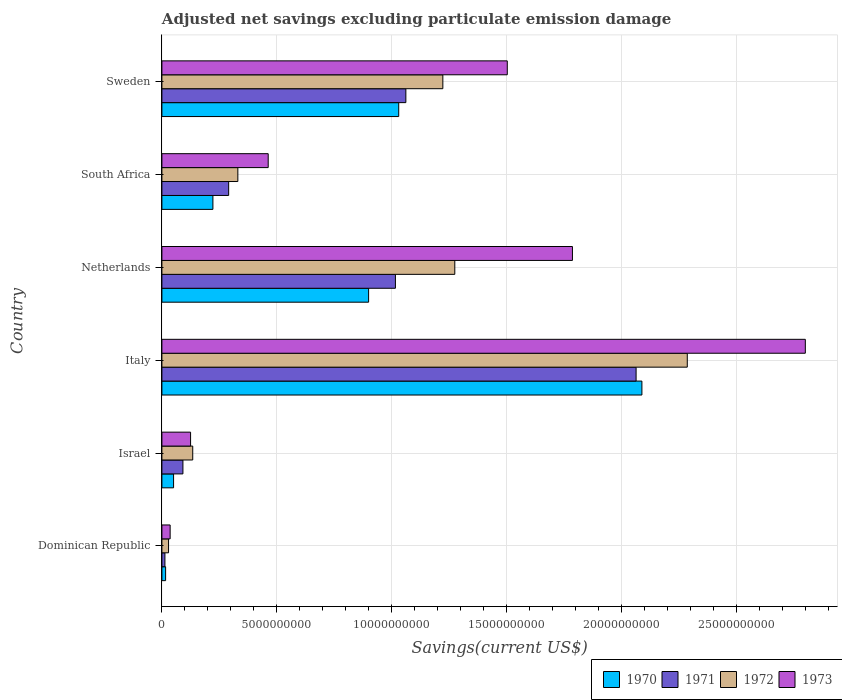How many groups of bars are there?
Provide a short and direct response. 6. How many bars are there on the 1st tick from the top?
Keep it short and to the point. 4. How many bars are there on the 4th tick from the bottom?
Your answer should be compact. 4. What is the label of the 1st group of bars from the top?
Give a very brief answer. Sweden. In how many cases, is the number of bars for a given country not equal to the number of legend labels?
Give a very brief answer. 0. What is the adjusted net savings in 1973 in Israel?
Your answer should be very brief. 1.25e+09. Across all countries, what is the maximum adjusted net savings in 1973?
Your answer should be very brief. 2.80e+1. Across all countries, what is the minimum adjusted net savings in 1972?
Your answer should be compact. 2.89e+08. In which country was the adjusted net savings in 1972 maximum?
Ensure brevity in your answer.  Italy. In which country was the adjusted net savings in 1970 minimum?
Provide a short and direct response. Dominican Republic. What is the total adjusted net savings in 1972 in the graph?
Ensure brevity in your answer.  5.27e+1. What is the difference between the adjusted net savings in 1972 in Dominican Republic and that in Netherlands?
Your answer should be very brief. -1.24e+1. What is the difference between the adjusted net savings in 1971 in Dominican Republic and the adjusted net savings in 1972 in South Africa?
Provide a succinct answer. -3.17e+09. What is the average adjusted net savings in 1972 per country?
Keep it short and to the point. 8.79e+09. What is the difference between the adjusted net savings in 1972 and adjusted net savings in 1973 in Sweden?
Offer a terse response. -2.80e+09. In how many countries, is the adjusted net savings in 1973 greater than 1000000000 US$?
Make the answer very short. 5. What is the ratio of the adjusted net savings in 1973 in Israel to that in South Africa?
Offer a terse response. 0.27. What is the difference between the highest and the second highest adjusted net savings in 1970?
Offer a terse response. 1.06e+1. What is the difference between the highest and the lowest adjusted net savings in 1971?
Provide a short and direct response. 2.05e+1. Is the sum of the adjusted net savings in 1971 in Italy and Netherlands greater than the maximum adjusted net savings in 1973 across all countries?
Your response must be concise. Yes. Is it the case that in every country, the sum of the adjusted net savings in 1971 and adjusted net savings in 1973 is greater than the sum of adjusted net savings in 1970 and adjusted net savings in 1972?
Offer a very short reply. No. What does the 4th bar from the bottom in Italy represents?
Offer a very short reply. 1973. Are all the bars in the graph horizontal?
Give a very brief answer. Yes. Are the values on the major ticks of X-axis written in scientific E-notation?
Your answer should be compact. No. Does the graph contain any zero values?
Offer a terse response. No. What is the title of the graph?
Offer a terse response. Adjusted net savings excluding particulate emission damage. What is the label or title of the X-axis?
Keep it short and to the point. Savings(current US$). What is the Savings(current US$) in 1970 in Dominican Republic?
Your response must be concise. 1.61e+08. What is the Savings(current US$) of 1971 in Dominican Republic?
Ensure brevity in your answer.  1.32e+08. What is the Savings(current US$) of 1972 in Dominican Republic?
Provide a short and direct response. 2.89e+08. What is the Savings(current US$) of 1973 in Dominican Republic?
Your response must be concise. 3.58e+08. What is the Savings(current US$) of 1970 in Israel?
Your response must be concise. 5.08e+08. What is the Savings(current US$) in 1971 in Israel?
Your answer should be very brief. 9.14e+08. What is the Savings(current US$) in 1972 in Israel?
Offer a terse response. 1.34e+09. What is the Savings(current US$) in 1973 in Israel?
Make the answer very short. 1.25e+09. What is the Savings(current US$) in 1970 in Italy?
Keep it short and to the point. 2.09e+1. What is the Savings(current US$) of 1971 in Italy?
Provide a short and direct response. 2.06e+1. What is the Savings(current US$) of 1972 in Italy?
Provide a short and direct response. 2.28e+1. What is the Savings(current US$) in 1973 in Italy?
Give a very brief answer. 2.80e+1. What is the Savings(current US$) of 1970 in Netherlands?
Offer a terse response. 8.99e+09. What is the Savings(current US$) in 1971 in Netherlands?
Give a very brief answer. 1.02e+1. What is the Savings(current US$) in 1972 in Netherlands?
Ensure brevity in your answer.  1.27e+1. What is the Savings(current US$) of 1973 in Netherlands?
Provide a succinct answer. 1.79e+1. What is the Savings(current US$) in 1970 in South Africa?
Provide a short and direct response. 2.22e+09. What is the Savings(current US$) in 1971 in South Africa?
Offer a terse response. 2.90e+09. What is the Savings(current US$) in 1972 in South Africa?
Provide a short and direct response. 3.30e+09. What is the Savings(current US$) of 1973 in South Africa?
Keep it short and to the point. 4.62e+09. What is the Savings(current US$) of 1970 in Sweden?
Your response must be concise. 1.03e+1. What is the Savings(current US$) of 1971 in Sweden?
Your answer should be compact. 1.06e+1. What is the Savings(current US$) in 1972 in Sweden?
Give a very brief answer. 1.22e+1. What is the Savings(current US$) of 1973 in Sweden?
Provide a succinct answer. 1.50e+1. Across all countries, what is the maximum Savings(current US$) in 1970?
Keep it short and to the point. 2.09e+1. Across all countries, what is the maximum Savings(current US$) of 1971?
Offer a very short reply. 2.06e+1. Across all countries, what is the maximum Savings(current US$) of 1972?
Offer a very short reply. 2.28e+1. Across all countries, what is the maximum Savings(current US$) of 1973?
Provide a short and direct response. 2.80e+1. Across all countries, what is the minimum Savings(current US$) in 1970?
Give a very brief answer. 1.61e+08. Across all countries, what is the minimum Savings(current US$) in 1971?
Provide a succinct answer. 1.32e+08. Across all countries, what is the minimum Savings(current US$) of 1972?
Your answer should be very brief. 2.89e+08. Across all countries, what is the minimum Savings(current US$) of 1973?
Offer a very short reply. 3.58e+08. What is the total Savings(current US$) of 1970 in the graph?
Give a very brief answer. 4.30e+1. What is the total Savings(current US$) of 1971 in the graph?
Offer a terse response. 4.53e+1. What is the total Savings(current US$) in 1972 in the graph?
Your response must be concise. 5.27e+1. What is the total Savings(current US$) in 1973 in the graph?
Provide a short and direct response. 6.71e+1. What is the difference between the Savings(current US$) in 1970 in Dominican Republic and that in Israel?
Provide a succinct answer. -3.47e+08. What is the difference between the Savings(current US$) in 1971 in Dominican Republic and that in Israel?
Offer a terse response. -7.83e+08. What is the difference between the Savings(current US$) in 1972 in Dominican Republic and that in Israel?
Keep it short and to the point. -1.05e+09. What is the difference between the Savings(current US$) in 1973 in Dominican Republic and that in Israel?
Provide a short and direct response. -8.89e+08. What is the difference between the Savings(current US$) of 1970 in Dominican Republic and that in Italy?
Provide a succinct answer. -2.07e+1. What is the difference between the Savings(current US$) in 1971 in Dominican Republic and that in Italy?
Your response must be concise. -2.05e+1. What is the difference between the Savings(current US$) of 1972 in Dominican Republic and that in Italy?
Offer a terse response. -2.26e+1. What is the difference between the Savings(current US$) of 1973 in Dominican Republic and that in Italy?
Provide a succinct answer. -2.76e+1. What is the difference between the Savings(current US$) of 1970 in Dominican Republic and that in Netherlands?
Make the answer very short. -8.83e+09. What is the difference between the Savings(current US$) of 1971 in Dominican Republic and that in Netherlands?
Make the answer very short. -1.00e+1. What is the difference between the Savings(current US$) in 1972 in Dominican Republic and that in Netherlands?
Provide a short and direct response. -1.24e+1. What is the difference between the Savings(current US$) in 1973 in Dominican Republic and that in Netherlands?
Provide a short and direct response. -1.75e+1. What is the difference between the Savings(current US$) of 1970 in Dominican Republic and that in South Africa?
Your response must be concise. -2.06e+09. What is the difference between the Savings(current US$) of 1971 in Dominican Republic and that in South Africa?
Offer a terse response. -2.77e+09. What is the difference between the Savings(current US$) in 1972 in Dominican Republic and that in South Africa?
Make the answer very short. -3.01e+09. What is the difference between the Savings(current US$) in 1973 in Dominican Republic and that in South Africa?
Your answer should be very brief. -4.26e+09. What is the difference between the Savings(current US$) in 1970 in Dominican Republic and that in Sweden?
Provide a short and direct response. -1.01e+1. What is the difference between the Savings(current US$) in 1971 in Dominican Republic and that in Sweden?
Your answer should be compact. -1.05e+1. What is the difference between the Savings(current US$) of 1972 in Dominican Republic and that in Sweden?
Your answer should be compact. -1.19e+1. What is the difference between the Savings(current US$) in 1973 in Dominican Republic and that in Sweden?
Your answer should be compact. -1.47e+1. What is the difference between the Savings(current US$) of 1970 in Israel and that in Italy?
Make the answer very short. -2.04e+1. What is the difference between the Savings(current US$) in 1971 in Israel and that in Italy?
Provide a short and direct response. -1.97e+1. What is the difference between the Savings(current US$) of 1972 in Israel and that in Italy?
Offer a terse response. -2.15e+1. What is the difference between the Savings(current US$) of 1973 in Israel and that in Italy?
Keep it short and to the point. -2.67e+1. What is the difference between the Savings(current US$) in 1970 in Israel and that in Netherlands?
Provide a short and direct response. -8.48e+09. What is the difference between the Savings(current US$) of 1971 in Israel and that in Netherlands?
Provide a succinct answer. -9.24e+09. What is the difference between the Savings(current US$) in 1972 in Israel and that in Netherlands?
Offer a terse response. -1.14e+1. What is the difference between the Savings(current US$) in 1973 in Israel and that in Netherlands?
Provide a short and direct response. -1.66e+1. What is the difference between the Savings(current US$) of 1970 in Israel and that in South Africa?
Your answer should be compact. -1.71e+09. What is the difference between the Savings(current US$) of 1971 in Israel and that in South Africa?
Keep it short and to the point. -1.99e+09. What is the difference between the Savings(current US$) in 1972 in Israel and that in South Africa?
Make the answer very short. -1.96e+09. What is the difference between the Savings(current US$) of 1973 in Israel and that in South Africa?
Provide a short and direct response. -3.38e+09. What is the difference between the Savings(current US$) of 1970 in Israel and that in Sweden?
Give a very brief answer. -9.79e+09. What is the difference between the Savings(current US$) in 1971 in Israel and that in Sweden?
Provide a succinct answer. -9.69e+09. What is the difference between the Savings(current US$) of 1972 in Israel and that in Sweden?
Your answer should be very brief. -1.09e+1. What is the difference between the Savings(current US$) of 1973 in Israel and that in Sweden?
Provide a short and direct response. -1.38e+1. What is the difference between the Savings(current US$) of 1970 in Italy and that in Netherlands?
Provide a succinct answer. 1.19e+1. What is the difference between the Savings(current US$) of 1971 in Italy and that in Netherlands?
Give a very brief answer. 1.05e+1. What is the difference between the Savings(current US$) in 1972 in Italy and that in Netherlands?
Offer a very short reply. 1.01e+1. What is the difference between the Savings(current US$) of 1973 in Italy and that in Netherlands?
Provide a short and direct response. 1.01e+1. What is the difference between the Savings(current US$) in 1970 in Italy and that in South Africa?
Provide a succinct answer. 1.87e+1. What is the difference between the Savings(current US$) in 1971 in Italy and that in South Africa?
Give a very brief answer. 1.77e+1. What is the difference between the Savings(current US$) in 1972 in Italy and that in South Africa?
Your answer should be compact. 1.95e+1. What is the difference between the Savings(current US$) in 1973 in Italy and that in South Africa?
Offer a very short reply. 2.34e+1. What is the difference between the Savings(current US$) in 1970 in Italy and that in Sweden?
Your answer should be very brief. 1.06e+1. What is the difference between the Savings(current US$) in 1971 in Italy and that in Sweden?
Make the answer very short. 1.00e+1. What is the difference between the Savings(current US$) in 1972 in Italy and that in Sweden?
Provide a succinct answer. 1.06e+1. What is the difference between the Savings(current US$) of 1973 in Italy and that in Sweden?
Provide a succinct answer. 1.30e+1. What is the difference between the Savings(current US$) of 1970 in Netherlands and that in South Africa?
Ensure brevity in your answer.  6.77e+09. What is the difference between the Savings(current US$) of 1971 in Netherlands and that in South Africa?
Provide a short and direct response. 7.25e+09. What is the difference between the Savings(current US$) in 1972 in Netherlands and that in South Africa?
Give a very brief answer. 9.43e+09. What is the difference between the Savings(current US$) of 1973 in Netherlands and that in South Africa?
Give a very brief answer. 1.32e+1. What is the difference between the Savings(current US$) of 1970 in Netherlands and that in Sweden?
Provide a short and direct response. -1.31e+09. What is the difference between the Savings(current US$) of 1971 in Netherlands and that in Sweden?
Make the answer very short. -4.54e+08. What is the difference between the Savings(current US$) of 1972 in Netherlands and that in Sweden?
Your answer should be compact. 5.20e+08. What is the difference between the Savings(current US$) in 1973 in Netherlands and that in Sweden?
Ensure brevity in your answer.  2.83e+09. What is the difference between the Savings(current US$) in 1970 in South Africa and that in Sweden?
Keep it short and to the point. -8.08e+09. What is the difference between the Savings(current US$) in 1971 in South Africa and that in Sweden?
Provide a short and direct response. -7.70e+09. What is the difference between the Savings(current US$) in 1972 in South Africa and that in Sweden?
Provide a succinct answer. -8.91e+09. What is the difference between the Savings(current US$) of 1973 in South Africa and that in Sweden?
Make the answer very short. -1.04e+1. What is the difference between the Savings(current US$) in 1970 in Dominican Republic and the Savings(current US$) in 1971 in Israel?
Ensure brevity in your answer.  -7.53e+08. What is the difference between the Savings(current US$) in 1970 in Dominican Republic and the Savings(current US$) in 1972 in Israel?
Offer a terse response. -1.18e+09. What is the difference between the Savings(current US$) of 1970 in Dominican Republic and the Savings(current US$) of 1973 in Israel?
Provide a short and direct response. -1.09e+09. What is the difference between the Savings(current US$) of 1971 in Dominican Republic and the Savings(current US$) of 1972 in Israel?
Your response must be concise. -1.21e+09. What is the difference between the Savings(current US$) of 1971 in Dominican Republic and the Savings(current US$) of 1973 in Israel?
Your answer should be compact. -1.12e+09. What is the difference between the Savings(current US$) of 1972 in Dominican Republic and the Savings(current US$) of 1973 in Israel?
Provide a short and direct response. -9.58e+08. What is the difference between the Savings(current US$) in 1970 in Dominican Republic and the Savings(current US$) in 1971 in Italy?
Provide a short and direct response. -2.05e+1. What is the difference between the Savings(current US$) of 1970 in Dominican Republic and the Savings(current US$) of 1972 in Italy?
Your answer should be very brief. -2.27e+1. What is the difference between the Savings(current US$) in 1970 in Dominican Republic and the Savings(current US$) in 1973 in Italy?
Provide a short and direct response. -2.78e+1. What is the difference between the Savings(current US$) of 1971 in Dominican Republic and the Savings(current US$) of 1972 in Italy?
Offer a very short reply. -2.27e+1. What is the difference between the Savings(current US$) in 1971 in Dominican Republic and the Savings(current US$) in 1973 in Italy?
Your answer should be very brief. -2.78e+1. What is the difference between the Savings(current US$) of 1972 in Dominican Republic and the Savings(current US$) of 1973 in Italy?
Give a very brief answer. -2.77e+1. What is the difference between the Savings(current US$) of 1970 in Dominican Republic and the Savings(current US$) of 1971 in Netherlands?
Offer a terse response. -9.99e+09. What is the difference between the Savings(current US$) in 1970 in Dominican Republic and the Savings(current US$) in 1972 in Netherlands?
Offer a terse response. -1.26e+1. What is the difference between the Savings(current US$) of 1970 in Dominican Republic and the Savings(current US$) of 1973 in Netherlands?
Offer a very short reply. -1.77e+1. What is the difference between the Savings(current US$) in 1971 in Dominican Republic and the Savings(current US$) in 1972 in Netherlands?
Give a very brief answer. -1.26e+1. What is the difference between the Savings(current US$) of 1971 in Dominican Republic and the Savings(current US$) of 1973 in Netherlands?
Offer a very short reply. -1.77e+1. What is the difference between the Savings(current US$) of 1972 in Dominican Republic and the Savings(current US$) of 1973 in Netherlands?
Your response must be concise. -1.76e+1. What is the difference between the Savings(current US$) in 1970 in Dominican Republic and the Savings(current US$) in 1971 in South Africa?
Give a very brief answer. -2.74e+09. What is the difference between the Savings(current US$) of 1970 in Dominican Republic and the Savings(current US$) of 1972 in South Africa?
Offer a very short reply. -3.14e+09. What is the difference between the Savings(current US$) of 1970 in Dominican Republic and the Savings(current US$) of 1973 in South Africa?
Provide a short and direct response. -4.46e+09. What is the difference between the Savings(current US$) in 1971 in Dominican Republic and the Savings(current US$) in 1972 in South Africa?
Offer a very short reply. -3.17e+09. What is the difference between the Savings(current US$) of 1971 in Dominican Republic and the Savings(current US$) of 1973 in South Africa?
Your response must be concise. -4.49e+09. What is the difference between the Savings(current US$) in 1972 in Dominican Republic and the Savings(current US$) in 1973 in South Africa?
Ensure brevity in your answer.  -4.33e+09. What is the difference between the Savings(current US$) of 1970 in Dominican Republic and the Savings(current US$) of 1971 in Sweden?
Make the answer very short. -1.04e+1. What is the difference between the Savings(current US$) in 1970 in Dominican Republic and the Savings(current US$) in 1972 in Sweden?
Offer a terse response. -1.21e+1. What is the difference between the Savings(current US$) of 1970 in Dominican Republic and the Savings(current US$) of 1973 in Sweden?
Give a very brief answer. -1.49e+1. What is the difference between the Savings(current US$) in 1971 in Dominican Republic and the Savings(current US$) in 1972 in Sweden?
Provide a short and direct response. -1.21e+1. What is the difference between the Savings(current US$) of 1971 in Dominican Republic and the Savings(current US$) of 1973 in Sweden?
Offer a very short reply. -1.49e+1. What is the difference between the Savings(current US$) of 1972 in Dominican Republic and the Savings(current US$) of 1973 in Sweden?
Offer a very short reply. -1.47e+1. What is the difference between the Savings(current US$) in 1970 in Israel and the Savings(current US$) in 1971 in Italy?
Your answer should be very brief. -2.01e+1. What is the difference between the Savings(current US$) in 1970 in Israel and the Savings(current US$) in 1972 in Italy?
Offer a terse response. -2.23e+1. What is the difference between the Savings(current US$) in 1970 in Israel and the Savings(current US$) in 1973 in Italy?
Ensure brevity in your answer.  -2.75e+1. What is the difference between the Savings(current US$) in 1971 in Israel and the Savings(current US$) in 1972 in Italy?
Keep it short and to the point. -2.19e+1. What is the difference between the Savings(current US$) of 1971 in Israel and the Savings(current US$) of 1973 in Italy?
Your answer should be very brief. -2.71e+1. What is the difference between the Savings(current US$) in 1972 in Israel and the Savings(current US$) in 1973 in Italy?
Offer a terse response. -2.66e+1. What is the difference between the Savings(current US$) in 1970 in Israel and the Savings(current US$) in 1971 in Netherlands?
Provide a short and direct response. -9.65e+09. What is the difference between the Savings(current US$) in 1970 in Israel and the Savings(current US$) in 1972 in Netherlands?
Offer a very short reply. -1.22e+1. What is the difference between the Savings(current US$) of 1970 in Israel and the Savings(current US$) of 1973 in Netherlands?
Provide a succinct answer. -1.73e+1. What is the difference between the Savings(current US$) of 1971 in Israel and the Savings(current US$) of 1972 in Netherlands?
Provide a succinct answer. -1.18e+1. What is the difference between the Savings(current US$) in 1971 in Israel and the Savings(current US$) in 1973 in Netherlands?
Your answer should be compact. -1.69e+1. What is the difference between the Savings(current US$) in 1972 in Israel and the Savings(current US$) in 1973 in Netherlands?
Ensure brevity in your answer.  -1.65e+1. What is the difference between the Savings(current US$) of 1970 in Israel and the Savings(current US$) of 1971 in South Africa?
Offer a very short reply. -2.39e+09. What is the difference between the Savings(current US$) in 1970 in Israel and the Savings(current US$) in 1972 in South Africa?
Your answer should be very brief. -2.79e+09. What is the difference between the Savings(current US$) in 1970 in Israel and the Savings(current US$) in 1973 in South Africa?
Give a very brief answer. -4.11e+09. What is the difference between the Savings(current US$) of 1971 in Israel and the Savings(current US$) of 1972 in South Africa?
Your response must be concise. -2.39e+09. What is the difference between the Savings(current US$) of 1971 in Israel and the Savings(current US$) of 1973 in South Africa?
Make the answer very short. -3.71e+09. What is the difference between the Savings(current US$) of 1972 in Israel and the Savings(current US$) of 1973 in South Africa?
Give a very brief answer. -3.28e+09. What is the difference between the Savings(current US$) in 1970 in Israel and the Savings(current US$) in 1971 in Sweden?
Your response must be concise. -1.01e+1. What is the difference between the Savings(current US$) of 1970 in Israel and the Savings(current US$) of 1972 in Sweden?
Provide a succinct answer. -1.17e+1. What is the difference between the Savings(current US$) in 1970 in Israel and the Savings(current US$) in 1973 in Sweden?
Make the answer very short. -1.45e+1. What is the difference between the Savings(current US$) in 1971 in Israel and the Savings(current US$) in 1972 in Sweden?
Your response must be concise. -1.13e+1. What is the difference between the Savings(current US$) in 1971 in Israel and the Savings(current US$) in 1973 in Sweden?
Provide a succinct answer. -1.41e+1. What is the difference between the Savings(current US$) of 1972 in Israel and the Savings(current US$) of 1973 in Sweden?
Provide a succinct answer. -1.37e+1. What is the difference between the Savings(current US$) in 1970 in Italy and the Savings(current US$) in 1971 in Netherlands?
Give a very brief answer. 1.07e+1. What is the difference between the Savings(current US$) of 1970 in Italy and the Savings(current US$) of 1972 in Netherlands?
Offer a terse response. 8.14e+09. What is the difference between the Savings(current US$) in 1970 in Italy and the Savings(current US$) in 1973 in Netherlands?
Offer a terse response. 3.02e+09. What is the difference between the Savings(current US$) in 1971 in Italy and the Savings(current US$) in 1972 in Netherlands?
Offer a terse response. 7.88e+09. What is the difference between the Savings(current US$) in 1971 in Italy and the Savings(current US$) in 1973 in Netherlands?
Your answer should be very brief. 2.77e+09. What is the difference between the Savings(current US$) of 1972 in Italy and the Savings(current US$) of 1973 in Netherlands?
Make the answer very short. 4.99e+09. What is the difference between the Savings(current US$) of 1970 in Italy and the Savings(current US$) of 1971 in South Africa?
Offer a very short reply. 1.80e+1. What is the difference between the Savings(current US$) of 1970 in Italy and the Savings(current US$) of 1972 in South Africa?
Ensure brevity in your answer.  1.76e+1. What is the difference between the Savings(current US$) in 1970 in Italy and the Savings(current US$) in 1973 in South Africa?
Give a very brief answer. 1.62e+1. What is the difference between the Savings(current US$) in 1971 in Italy and the Savings(current US$) in 1972 in South Africa?
Give a very brief answer. 1.73e+1. What is the difference between the Savings(current US$) of 1971 in Italy and the Savings(current US$) of 1973 in South Africa?
Your answer should be very brief. 1.60e+1. What is the difference between the Savings(current US$) in 1972 in Italy and the Savings(current US$) in 1973 in South Africa?
Make the answer very short. 1.82e+1. What is the difference between the Savings(current US$) of 1970 in Italy and the Savings(current US$) of 1971 in Sweden?
Ensure brevity in your answer.  1.03e+1. What is the difference between the Savings(current US$) of 1970 in Italy and the Savings(current US$) of 1972 in Sweden?
Offer a very short reply. 8.66e+09. What is the difference between the Savings(current US$) in 1970 in Italy and the Savings(current US$) in 1973 in Sweden?
Keep it short and to the point. 5.85e+09. What is the difference between the Savings(current US$) in 1971 in Italy and the Savings(current US$) in 1972 in Sweden?
Offer a very short reply. 8.40e+09. What is the difference between the Savings(current US$) of 1971 in Italy and the Savings(current US$) of 1973 in Sweden?
Keep it short and to the point. 5.60e+09. What is the difference between the Savings(current US$) in 1972 in Italy and the Savings(current US$) in 1973 in Sweden?
Keep it short and to the point. 7.83e+09. What is the difference between the Savings(current US$) of 1970 in Netherlands and the Savings(current US$) of 1971 in South Africa?
Your answer should be compact. 6.09e+09. What is the difference between the Savings(current US$) in 1970 in Netherlands and the Savings(current US$) in 1972 in South Africa?
Offer a very short reply. 5.69e+09. What is the difference between the Savings(current US$) in 1970 in Netherlands and the Savings(current US$) in 1973 in South Africa?
Provide a succinct answer. 4.37e+09. What is the difference between the Savings(current US$) of 1971 in Netherlands and the Savings(current US$) of 1972 in South Africa?
Provide a succinct answer. 6.85e+09. What is the difference between the Savings(current US$) of 1971 in Netherlands and the Savings(current US$) of 1973 in South Africa?
Make the answer very short. 5.53e+09. What is the difference between the Savings(current US$) of 1972 in Netherlands and the Savings(current US$) of 1973 in South Africa?
Provide a succinct answer. 8.11e+09. What is the difference between the Savings(current US$) in 1970 in Netherlands and the Savings(current US$) in 1971 in Sweden?
Ensure brevity in your answer.  -1.62e+09. What is the difference between the Savings(current US$) of 1970 in Netherlands and the Savings(current US$) of 1972 in Sweden?
Make the answer very short. -3.23e+09. What is the difference between the Savings(current US$) in 1970 in Netherlands and the Savings(current US$) in 1973 in Sweden?
Make the answer very short. -6.03e+09. What is the difference between the Savings(current US$) in 1971 in Netherlands and the Savings(current US$) in 1972 in Sweden?
Offer a very short reply. -2.06e+09. What is the difference between the Savings(current US$) in 1971 in Netherlands and the Savings(current US$) in 1973 in Sweden?
Your answer should be compact. -4.86e+09. What is the difference between the Savings(current US$) in 1972 in Netherlands and the Savings(current US$) in 1973 in Sweden?
Offer a very short reply. -2.28e+09. What is the difference between the Savings(current US$) in 1970 in South Africa and the Savings(current US$) in 1971 in Sweden?
Provide a short and direct response. -8.39e+09. What is the difference between the Savings(current US$) in 1970 in South Africa and the Savings(current US$) in 1972 in Sweden?
Give a very brief answer. -1.00e+1. What is the difference between the Savings(current US$) of 1970 in South Africa and the Savings(current US$) of 1973 in Sweden?
Make the answer very short. -1.28e+1. What is the difference between the Savings(current US$) in 1971 in South Africa and the Savings(current US$) in 1972 in Sweden?
Make the answer very short. -9.31e+09. What is the difference between the Savings(current US$) of 1971 in South Africa and the Savings(current US$) of 1973 in Sweden?
Give a very brief answer. -1.21e+1. What is the difference between the Savings(current US$) of 1972 in South Africa and the Savings(current US$) of 1973 in Sweden?
Give a very brief answer. -1.17e+1. What is the average Savings(current US$) of 1970 per country?
Give a very brief answer. 7.17e+09. What is the average Savings(current US$) of 1971 per country?
Offer a very short reply. 7.55e+09. What is the average Savings(current US$) in 1972 per country?
Make the answer very short. 8.79e+09. What is the average Savings(current US$) in 1973 per country?
Make the answer very short. 1.12e+1. What is the difference between the Savings(current US$) of 1970 and Savings(current US$) of 1971 in Dominican Republic?
Keep it short and to the point. 2.96e+07. What is the difference between the Savings(current US$) of 1970 and Savings(current US$) of 1972 in Dominican Republic?
Ensure brevity in your answer.  -1.28e+08. What is the difference between the Savings(current US$) of 1970 and Savings(current US$) of 1973 in Dominican Republic?
Provide a short and direct response. -1.97e+08. What is the difference between the Savings(current US$) of 1971 and Savings(current US$) of 1972 in Dominican Republic?
Your answer should be very brief. -1.57e+08. What is the difference between the Savings(current US$) in 1971 and Savings(current US$) in 1973 in Dominican Republic?
Provide a short and direct response. -2.27e+08. What is the difference between the Savings(current US$) of 1972 and Savings(current US$) of 1973 in Dominican Republic?
Offer a terse response. -6.95e+07. What is the difference between the Savings(current US$) in 1970 and Savings(current US$) in 1971 in Israel?
Provide a short and direct response. -4.06e+08. What is the difference between the Savings(current US$) of 1970 and Savings(current US$) of 1972 in Israel?
Provide a succinct answer. -8.33e+08. What is the difference between the Savings(current US$) in 1970 and Savings(current US$) in 1973 in Israel?
Make the answer very short. -7.39e+08. What is the difference between the Savings(current US$) of 1971 and Savings(current US$) of 1972 in Israel?
Offer a terse response. -4.27e+08. What is the difference between the Savings(current US$) of 1971 and Savings(current US$) of 1973 in Israel?
Give a very brief answer. -3.33e+08. What is the difference between the Savings(current US$) in 1972 and Savings(current US$) in 1973 in Israel?
Your response must be concise. 9.40e+07. What is the difference between the Savings(current US$) of 1970 and Savings(current US$) of 1971 in Italy?
Ensure brevity in your answer.  2.53e+08. What is the difference between the Savings(current US$) of 1970 and Savings(current US$) of 1972 in Italy?
Keep it short and to the point. -1.97e+09. What is the difference between the Savings(current US$) of 1970 and Savings(current US$) of 1973 in Italy?
Give a very brief answer. -7.11e+09. What is the difference between the Savings(current US$) of 1971 and Savings(current US$) of 1972 in Italy?
Ensure brevity in your answer.  -2.23e+09. What is the difference between the Savings(current US$) in 1971 and Savings(current US$) in 1973 in Italy?
Your answer should be compact. -7.36e+09. What is the difference between the Savings(current US$) in 1972 and Savings(current US$) in 1973 in Italy?
Give a very brief answer. -5.13e+09. What is the difference between the Savings(current US$) in 1970 and Savings(current US$) in 1971 in Netherlands?
Your answer should be compact. -1.17e+09. What is the difference between the Savings(current US$) of 1970 and Savings(current US$) of 1972 in Netherlands?
Ensure brevity in your answer.  -3.75e+09. What is the difference between the Savings(current US$) in 1970 and Savings(current US$) in 1973 in Netherlands?
Provide a short and direct response. -8.86e+09. What is the difference between the Savings(current US$) in 1971 and Savings(current US$) in 1972 in Netherlands?
Provide a short and direct response. -2.58e+09. What is the difference between the Savings(current US$) of 1971 and Savings(current US$) of 1973 in Netherlands?
Your response must be concise. -7.70e+09. What is the difference between the Savings(current US$) in 1972 and Savings(current US$) in 1973 in Netherlands?
Provide a succinct answer. -5.11e+09. What is the difference between the Savings(current US$) in 1970 and Savings(current US$) in 1971 in South Africa?
Offer a very short reply. -6.85e+08. What is the difference between the Savings(current US$) in 1970 and Savings(current US$) in 1972 in South Africa?
Provide a short and direct response. -1.08e+09. What is the difference between the Savings(current US$) of 1970 and Savings(current US$) of 1973 in South Africa?
Offer a terse response. -2.40e+09. What is the difference between the Savings(current US$) in 1971 and Savings(current US$) in 1972 in South Africa?
Your answer should be compact. -4.00e+08. What is the difference between the Savings(current US$) in 1971 and Savings(current US$) in 1973 in South Africa?
Give a very brief answer. -1.72e+09. What is the difference between the Savings(current US$) in 1972 and Savings(current US$) in 1973 in South Africa?
Offer a very short reply. -1.32e+09. What is the difference between the Savings(current US$) in 1970 and Savings(current US$) in 1971 in Sweden?
Your response must be concise. -3.10e+08. What is the difference between the Savings(current US$) in 1970 and Savings(current US$) in 1972 in Sweden?
Provide a succinct answer. -1.92e+09. What is the difference between the Savings(current US$) of 1970 and Savings(current US$) of 1973 in Sweden?
Offer a very short reply. -4.72e+09. What is the difference between the Savings(current US$) in 1971 and Savings(current US$) in 1972 in Sweden?
Offer a terse response. -1.61e+09. What is the difference between the Savings(current US$) of 1971 and Savings(current US$) of 1973 in Sweden?
Keep it short and to the point. -4.41e+09. What is the difference between the Savings(current US$) in 1972 and Savings(current US$) in 1973 in Sweden?
Provide a short and direct response. -2.80e+09. What is the ratio of the Savings(current US$) in 1970 in Dominican Republic to that in Israel?
Keep it short and to the point. 0.32. What is the ratio of the Savings(current US$) of 1971 in Dominican Republic to that in Israel?
Provide a short and direct response. 0.14. What is the ratio of the Savings(current US$) of 1972 in Dominican Republic to that in Israel?
Your answer should be compact. 0.22. What is the ratio of the Savings(current US$) in 1973 in Dominican Republic to that in Israel?
Offer a very short reply. 0.29. What is the ratio of the Savings(current US$) of 1970 in Dominican Republic to that in Italy?
Make the answer very short. 0.01. What is the ratio of the Savings(current US$) of 1971 in Dominican Republic to that in Italy?
Keep it short and to the point. 0.01. What is the ratio of the Savings(current US$) in 1972 in Dominican Republic to that in Italy?
Offer a very short reply. 0.01. What is the ratio of the Savings(current US$) in 1973 in Dominican Republic to that in Italy?
Provide a succinct answer. 0.01. What is the ratio of the Savings(current US$) of 1970 in Dominican Republic to that in Netherlands?
Offer a very short reply. 0.02. What is the ratio of the Savings(current US$) in 1971 in Dominican Republic to that in Netherlands?
Give a very brief answer. 0.01. What is the ratio of the Savings(current US$) of 1972 in Dominican Republic to that in Netherlands?
Ensure brevity in your answer.  0.02. What is the ratio of the Savings(current US$) of 1973 in Dominican Republic to that in Netherlands?
Offer a very short reply. 0.02. What is the ratio of the Savings(current US$) of 1970 in Dominican Republic to that in South Africa?
Keep it short and to the point. 0.07. What is the ratio of the Savings(current US$) in 1971 in Dominican Republic to that in South Africa?
Provide a succinct answer. 0.05. What is the ratio of the Savings(current US$) of 1972 in Dominican Republic to that in South Africa?
Keep it short and to the point. 0.09. What is the ratio of the Savings(current US$) in 1973 in Dominican Republic to that in South Africa?
Your response must be concise. 0.08. What is the ratio of the Savings(current US$) of 1970 in Dominican Republic to that in Sweden?
Provide a short and direct response. 0.02. What is the ratio of the Savings(current US$) of 1971 in Dominican Republic to that in Sweden?
Offer a very short reply. 0.01. What is the ratio of the Savings(current US$) in 1972 in Dominican Republic to that in Sweden?
Provide a succinct answer. 0.02. What is the ratio of the Savings(current US$) in 1973 in Dominican Republic to that in Sweden?
Offer a terse response. 0.02. What is the ratio of the Savings(current US$) in 1970 in Israel to that in Italy?
Your response must be concise. 0.02. What is the ratio of the Savings(current US$) in 1971 in Israel to that in Italy?
Give a very brief answer. 0.04. What is the ratio of the Savings(current US$) in 1972 in Israel to that in Italy?
Your answer should be very brief. 0.06. What is the ratio of the Savings(current US$) of 1973 in Israel to that in Italy?
Your answer should be compact. 0.04. What is the ratio of the Savings(current US$) of 1970 in Israel to that in Netherlands?
Offer a terse response. 0.06. What is the ratio of the Savings(current US$) of 1971 in Israel to that in Netherlands?
Provide a short and direct response. 0.09. What is the ratio of the Savings(current US$) of 1972 in Israel to that in Netherlands?
Give a very brief answer. 0.11. What is the ratio of the Savings(current US$) of 1973 in Israel to that in Netherlands?
Give a very brief answer. 0.07. What is the ratio of the Savings(current US$) of 1970 in Israel to that in South Africa?
Your response must be concise. 0.23. What is the ratio of the Savings(current US$) in 1971 in Israel to that in South Africa?
Your response must be concise. 0.32. What is the ratio of the Savings(current US$) of 1972 in Israel to that in South Africa?
Ensure brevity in your answer.  0.41. What is the ratio of the Savings(current US$) of 1973 in Israel to that in South Africa?
Offer a terse response. 0.27. What is the ratio of the Savings(current US$) of 1970 in Israel to that in Sweden?
Your answer should be very brief. 0.05. What is the ratio of the Savings(current US$) of 1971 in Israel to that in Sweden?
Ensure brevity in your answer.  0.09. What is the ratio of the Savings(current US$) of 1972 in Israel to that in Sweden?
Give a very brief answer. 0.11. What is the ratio of the Savings(current US$) of 1973 in Israel to that in Sweden?
Offer a very short reply. 0.08. What is the ratio of the Savings(current US$) of 1970 in Italy to that in Netherlands?
Your answer should be very brief. 2.32. What is the ratio of the Savings(current US$) in 1971 in Italy to that in Netherlands?
Ensure brevity in your answer.  2.03. What is the ratio of the Savings(current US$) of 1972 in Italy to that in Netherlands?
Your response must be concise. 1.79. What is the ratio of the Savings(current US$) of 1973 in Italy to that in Netherlands?
Your answer should be very brief. 1.57. What is the ratio of the Savings(current US$) of 1970 in Italy to that in South Africa?
Keep it short and to the point. 9.41. What is the ratio of the Savings(current US$) of 1971 in Italy to that in South Africa?
Give a very brief answer. 7.1. What is the ratio of the Savings(current US$) of 1972 in Italy to that in South Africa?
Your answer should be compact. 6.92. What is the ratio of the Savings(current US$) in 1973 in Italy to that in South Africa?
Ensure brevity in your answer.  6.05. What is the ratio of the Savings(current US$) of 1970 in Italy to that in Sweden?
Your response must be concise. 2.03. What is the ratio of the Savings(current US$) in 1971 in Italy to that in Sweden?
Your answer should be very brief. 1.94. What is the ratio of the Savings(current US$) of 1972 in Italy to that in Sweden?
Make the answer very short. 1.87. What is the ratio of the Savings(current US$) of 1973 in Italy to that in Sweden?
Offer a very short reply. 1.86. What is the ratio of the Savings(current US$) of 1970 in Netherlands to that in South Africa?
Provide a succinct answer. 4.05. What is the ratio of the Savings(current US$) in 1971 in Netherlands to that in South Africa?
Give a very brief answer. 3.5. What is the ratio of the Savings(current US$) in 1972 in Netherlands to that in South Africa?
Your answer should be compact. 3.86. What is the ratio of the Savings(current US$) of 1973 in Netherlands to that in South Africa?
Provide a short and direct response. 3.86. What is the ratio of the Savings(current US$) in 1970 in Netherlands to that in Sweden?
Make the answer very short. 0.87. What is the ratio of the Savings(current US$) in 1971 in Netherlands to that in Sweden?
Offer a terse response. 0.96. What is the ratio of the Savings(current US$) in 1972 in Netherlands to that in Sweden?
Your response must be concise. 1.04. What is the ratio of the Savings(current US$) in 1973 in Netherlands to that in Sweden?
Your answer should be very brief. 1.19. What is the ratio of the Savings(current US$) of 1970 in South Africa to that in Sweden?
Provide a succinct answer. 0.22. What is the ratio of the Savings(current US$) in 1971 in South Africa to that in Sweden?
Provide a succinct answer. 0.27. What is the ratio of the Savings(current US$) in 1972 in South Africa to that in Sweden?
Your answer should be compact. 0.27. What is the ratio of the Savings(current US$) in 1973 in South Africa to that in Sweden?
Ensure brevity in your answer.  0.31. What is the difference between the highest and the second highest Savings(current US$) in 1970?
Make the answer very short. 1.06e+1. What is the difference between the highest and the second highest Savings(current US$) in 1971?
Make the answer very short. 1.00e+1. What is the difference between the highest and the second highest Savings(current US$) of 1972?
Give a very brief answer. 1.01e+1. What is the difference between the highest and the second highest Savings(current US$) in 1973?
Ensure brevity in your answer.  1.01e+1. What is the difference between the highest and the lowest Savings(current US$) of 1970?
Provide a short and direct response. 2.07e+1. What is the difference between the highest and the lowest Savings(current US$) in 1971?
Give a very brief answer. 2.05e+1. What is the difference between the highest and the lowest Savings(current US$) in 1972?
Offer a very short reply. 2.26e+1. What is the difference between the highest and the lowest Savings(current US$) in 1973?
Provide a succinct answer. 2.76e+1. 